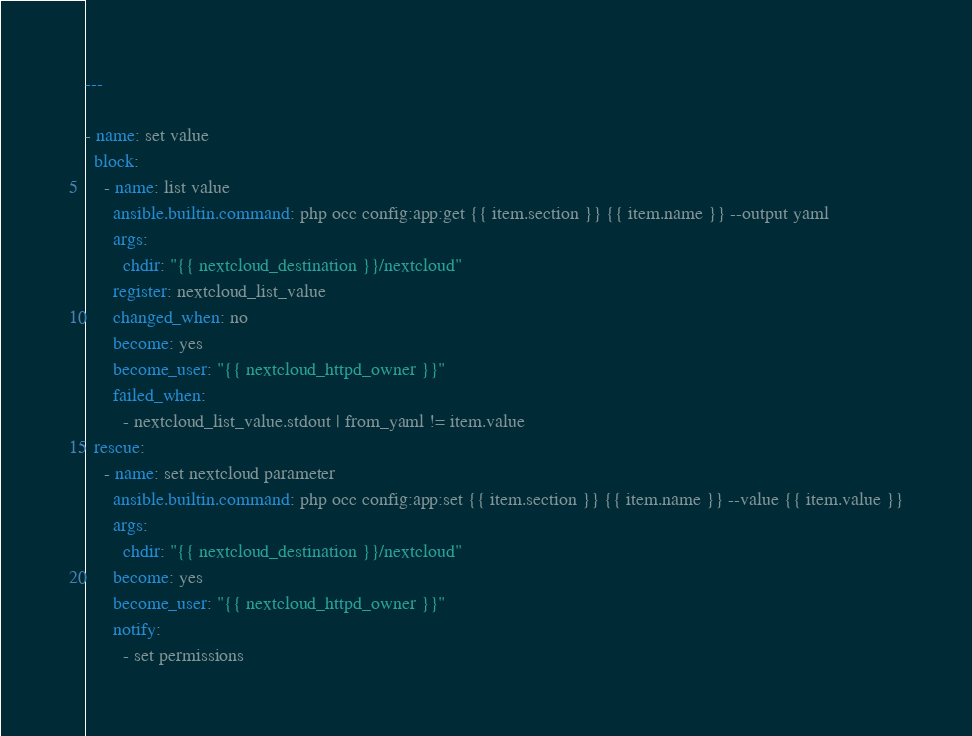<code> <loc_0><loc_0><loc_500><loc_500><_YAML_>---

- name: set value
  block:
    - name: list value
      ansible.builtin.command: php occ config:app:get {{ item.section }} {{ item.name }} --output yaml
      args:
        chdir: "{{ nextcloud_destination }}/nextcloud"
      register: nextcloud_list_value
      changed_when: no
      become: yes
      become_user: "{{ nextcloud_httpd_owner }}"
      failed_when:
        - nextcloud_list_value.stdout | from_yaml != item.value
  rescue:
    - name: set nextcloud parameter
      ansible.builtin.command: php occ config:app:set {{ item.section }} {{ item.name }} --value {{ item.value }}
      args:
        chdir: "{{ nextcloud_destination }}/nextcloud"
      become: yes
      become_user: "{{ nextcloud_httpd_owner }}"
      notify:
        - set permissions
</code> 